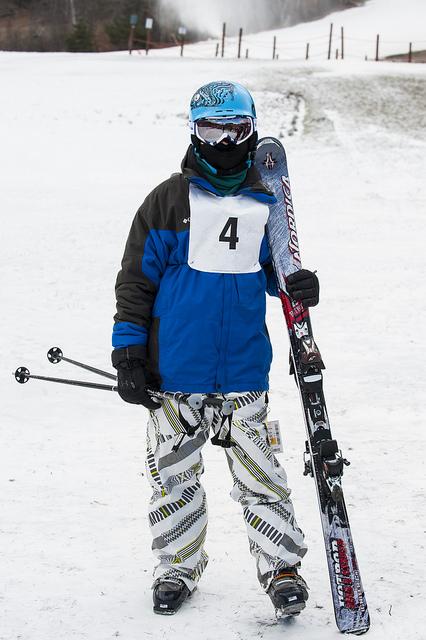What is this person holding in his left hand?
Concise answer only. Skis. What is the participant's number?
Write a very short answer. 4. Is the child's eyes safe?
Be succinct. Yes. What number is on his shirt?
Answer briefly. 4. What number is he wearing?
Short answer required. 4. What is this person wearing on his feet?
Quick response, please. Ski boots. What are on their feet?
Quick response, please. Shoes. 